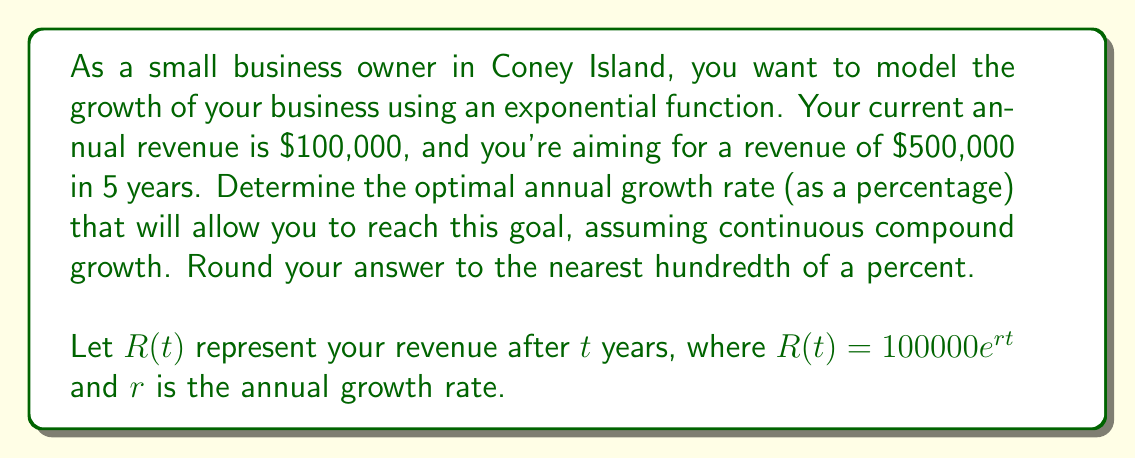Could you help me with this problem? To solve this problem, we'll follow these steps:

1) We know that at $t=0$, $R(0) = 100000$, and at $t=5$, we want $R(5) = 500000$.

2) Let's set up the equation using the exponential growth model:

   $R(5) = 100000e^{5r} = 500000$

3) Divide both sides by 100000:

   $e^{5r} = 5$

4) Take the natural logarithm of both sides:

   $\ln(e^{5r}) = \ln(5)$
   $5r = \ln(5)$

5) Solve for $r$:

   $r = \frac{\ln(5)}{5}$

6) Calculate the value:

   $r = \frac{\ln(5)}{5} \approx 0.3219$

7) Convert to a percentage by multiplying by 100:

   $32.19\%$

8) Round to the nearest hundredth of a percent:

   $32.19\%$

This growth rate represents continuous compound growth. It means that if your business grows continuously at this rate, your revenue will increase from $100,000 to $500,000 in exactly 5 years.
Answer: The optimal annual growth rate is approximately $32.19\%$. 